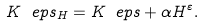Convert formula to latex. <formula><loc_0><loc_0><loc_500><loc_500>K ^ { \ } e p s _ { H } = K ^ { \ } e p s + \alpha H ^ { \varepsilon } .</formula> 